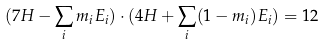Convert formula to latex. <formula><loc_0><loc_0><loc_500><loc_500>( 7 H - \sum _ { i } m _ { i } E _ { i } ) \cdot ( 4 H + \sum _ { i } ( 1 - m _ { i } ) E _ { i } ) = 1 2</formula> 